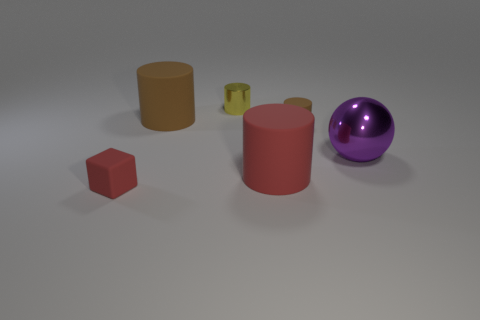Add 2 brown things. How many objects exist? 8 Subtract all big brown rubber cylinders. How many cylinders are left? 3 Subtract 2 cylinders. How many cylinders are left? 2 Subtract all yellow cylinders. How many cylinders are left? 3 Subtract 1 purple balls. How many objects are left? 5 Subtract all cylinders. How many objects are left? 2 Subtract all blue cylinders. Subtract all gray blocks. How many cylinders are left? 4 Subtract all yellow cubes. How many yellow cylinders are left? 1 Subtract all blue metal cubes. Subtract all small red things. How many objects are left? 5 Add 5 matte blocks. How many matte blocks are left? 6 